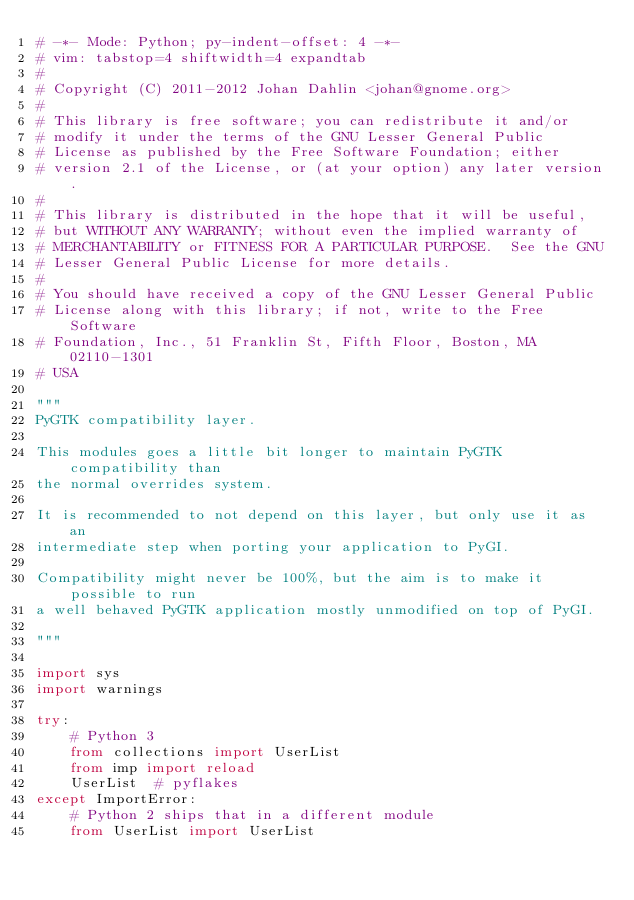<code> <loc_0><loc_0><loc_500><loc_500><_Python_># -*- Mode: Python; py-indent-offset: 4 -*-
# vim: tabstop=4 shiftwidth=4 expandtab
#
# Copyright (C) 2011-2012 Johan Dahlin <johan@gnome.org>
#
# This library is free software; you can redistribute it and/or
# modify it under the terms of the GNU Lesser General Public
# License as published by the Free Software Foundation; either
# version 2.1 of the License, or (at your option) any later version.
#
# This library is distributed in the hope that it will be useful,
# but WITHOUT ANY WARRANTY; without even the implied warranty of
# MERCHANTABILITY or FITNESS FOR A PARTICULAR PURPOSE.  See the GNU
# Lesser General Public License for more details.
#
# You should have received a copy of the GNU Lesser General Public
# License along with this library; if not, write to the Free Software
# Foundation, Inc., 51 Franklin St, Fifth Floor, Boston, MA  02110-1301
# USA

"""
PyGTK compatibility layer.

This modules goes a little bit longer to maintain PyGTK compatibility than
the normal overrides system.

It is recommended to not depend on this layer, but only use it as an
intermediate step when porting your application to PyGI.

Compatibility might never be 100%, but the aim is to make it possible to run
a well behaved PyGTK application mostly unmodified on top of PyGI.

"""

import sys
import warnings

try:
    # Python 3
    from collections import UserList
    from imp import reload
    UserList  # pyflakes
except ImportError:
    # Python 2 ships that in a different module
    from UserList import UserList</code> 